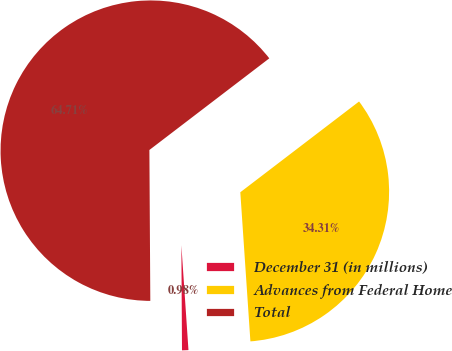Convert chart to OTSL. <chart><loc_0><loc_0><loc_500><loc_500><pie_chart><fcel>December 31 (in millions)<fcel>Advances from Federal Home<fcel>Total<nl><fcel>0.98%<fcel>34.31%<fcel>64.71%<nl></chart> 